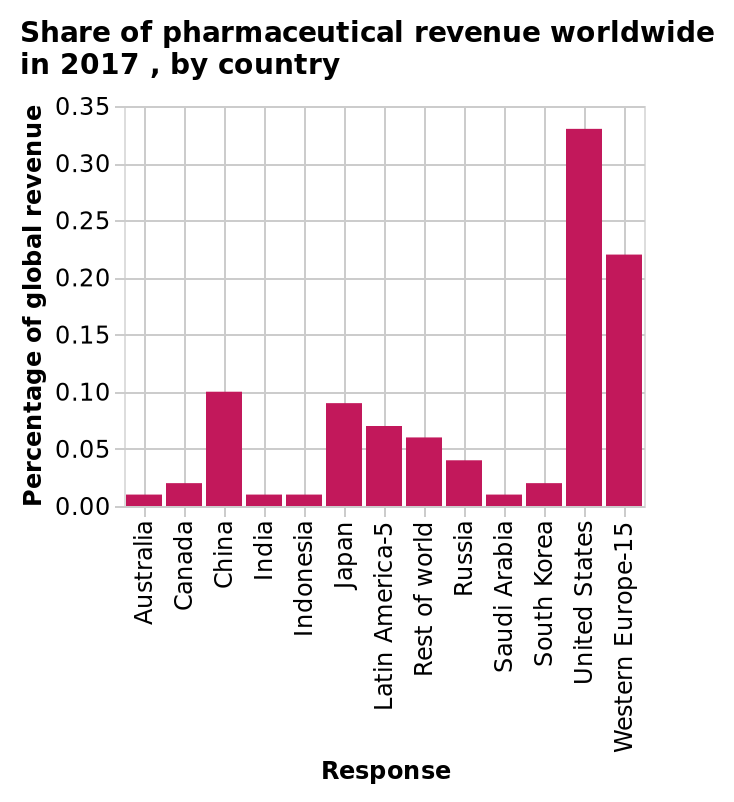<image>
What is the range of percentage of global revenue for all countries except the United States and Western Europe?  The percentage of global revenue for all other countries is between 0.05% and 0.1%. please describe the details of the chart Share of pharmaceutical revenue worldwide in 2017 , by country is a bar graph. A scale of range 0.00 to 0.35 can be found along the y-axis, labeled Percentage of global revenue. The x-axis shows Response with a categorical scale from Australia to Western Europe-15. What does the x-axis of the bar graph represent?  The x-axis of the bar graph represents the response categories from Australia to Western Europe-15. How much of global pharmaceutical revenue does Russia have?  Russia has less than 0.05% of global pharmaceutical revenue. Is the percentage of global revenue for all other countries over 0.1%? No. The percentage of global revenue for all other countries is between 0.05% and 0.1%. Does Russia have more than 0.05% of global pharmaceutical revenue? No. Russia has less than 0.05% of global pharmaceutical revenue. 